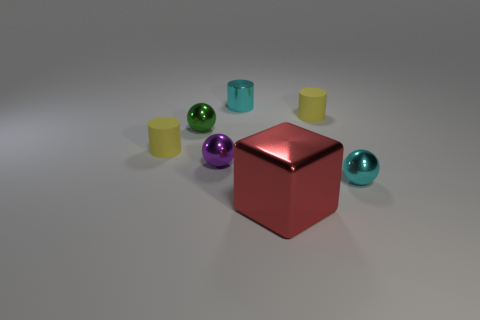Is there anything else that has the same size as the red metallic object?
Give a very brief answer. No. What number of rubber things are large brown cubes or cubes?
Your answer should be compact. 0. How many small metallic cylinders are the same color as the cube?
Your response must be concise. 0. Is there a ball that is in front of the tiny yellow matte object to the left of the large red metallic object?
Provide a succinct answer. Yes. What number of tiny things are both on the right side of the tiny purple metal object and behind the tiny purple sphere?
Your answer should be very brief. 2. How many big blocks have the same material as the large red object?
Offer a terse response. 0. There is a red block in front of the small yellow object that is right of the cyan metallic cylinder; what is its size?
Provide a succinct answer. Large. Is there a cyan object that has the same shape as the small green object?
Offer a very short reply. Yes. Do the cyan shiny thing that is left of the cyan metallic sphere and the sphere that is right of the shiny cylinder have the same size?
Provide a succinct answer. Yes. Is the number of small purple things that are on the right side of the small metallic cylinder less than the number of cyan metal objects that are on the left side of the big red shiny cube?
Give a very brief answer. Yes. 